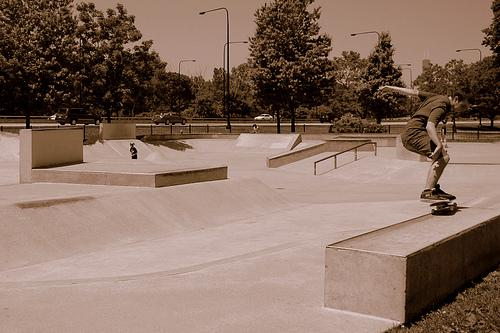Question: what is this place called?
Choices:
A. Skate park.
B. A tennis court.
C. A baseball field.
D. A football field.
Answer with the letter. Answer: A Question: why is the man on the wall?
Choices:
A. Posing for a picture.
B. Climbing it.
C. Skateboarding.
D. Spray painting graffiti.
Answer with the letter. Answer: C Question: who is in the picture?
Choices:
A. A woman wearing a yellow shirt.
B. A man wearing a black hat.
C. A man.
D. A guy skiing.
Answer with the letter. Answer: C 